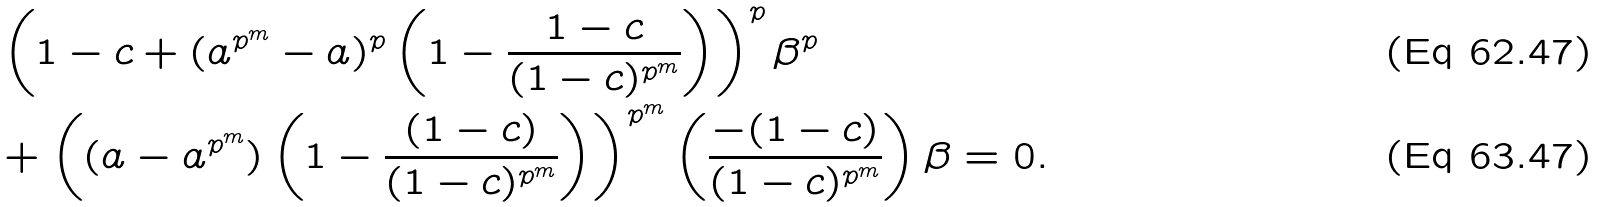<formula> <loc_0><loc_0><loc_500><loc_500>& \left ( 1 - c + ( a ^ { p ^ { m } } - a ) ^ { p } \left ( 1 - \frac { 1 - c } { ( 1 - c ) ^ { p ^ { m } } } \right ) \right ) ^ { p } \beta ^ { p } \\ & + \left ( ( a - a ^ { p ^ { m } } ) \left ( 1 - \frac { ( 1 - c ) } { ( 1 - c ) ^ { p ^ { m } } } \right ) \right ) ^ { p ^ { m } } \left ( \frac { - ( 1 - c ) } { ( 1 - c ) ^ { p ^ { m } } } \right ) \beta = 0 .</formula> 